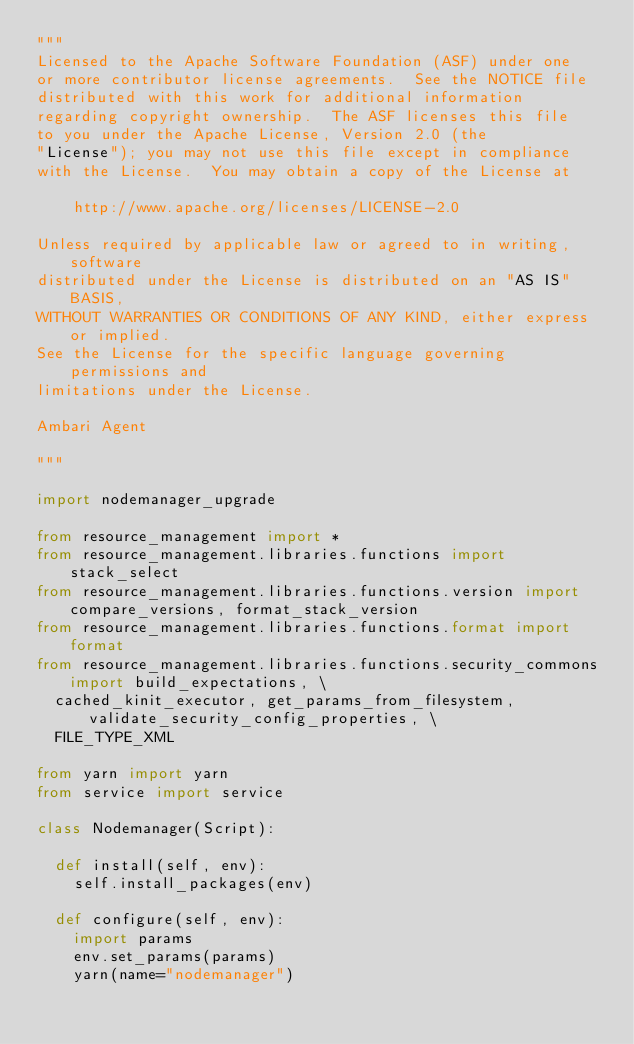Convert code to text. <code><loc_0><loc_0><loc_500><loc_500><_Python_>"""
Licensed to the Apache Software Foundation (ASF) under one
or more contributor license agreements.  See the NOTICE file
distributed with this work for additional information
regarding copyright ownership.  The ASF licenses this file
to you under the Apache License, Version 2.0 (the
"License"); you may not use this file except in compliance
with the License.  You may obtain a copy of the License at

    http://www.apache.org/licenses/LICENSE-2.0

Unless required by applicable law or agreed to in writing, software
distributed under the License is distributed on an "AS IS" BASIS,
WITHOUT WARRANTIES OR CONDITIONS OF ANY KIND, either express or implied.
See the License for the specific language governing permissions and
limitations under the License.

Ambari Agent

"""

import nodemanager_upgrade

from resource_management import *
from resource_management.libraries.functions import stack_select
from resource_management.libraries.functions.version import compare_versions, format_stack_version
from resource_management.libraries.functions.format import format
from resource_management.libraries.functions.security_commons import build_expectations, \
  cached_kinit_executor, get_params_from_filesystem, validate_security_config_properties, \
  FILE_TYPE_XML

from yarn import yarn
from service import service

class Nodemanager(Script):

  def install(self, env):
    self.install_packages(env)

  def configure(self, env):
    import params
    env.set_params(params)
    yarn(name="nodemanager")
</code> 